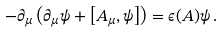<formula> <loc_0><loc_0><loc_500><loc_500>- \partial _ { \mu } \left ( \partial _ { \mu } \psi + \left [ A _ { \mu } , \psi \right ] \right ) = \epsilon ( A ) \psi \, .</formula> 